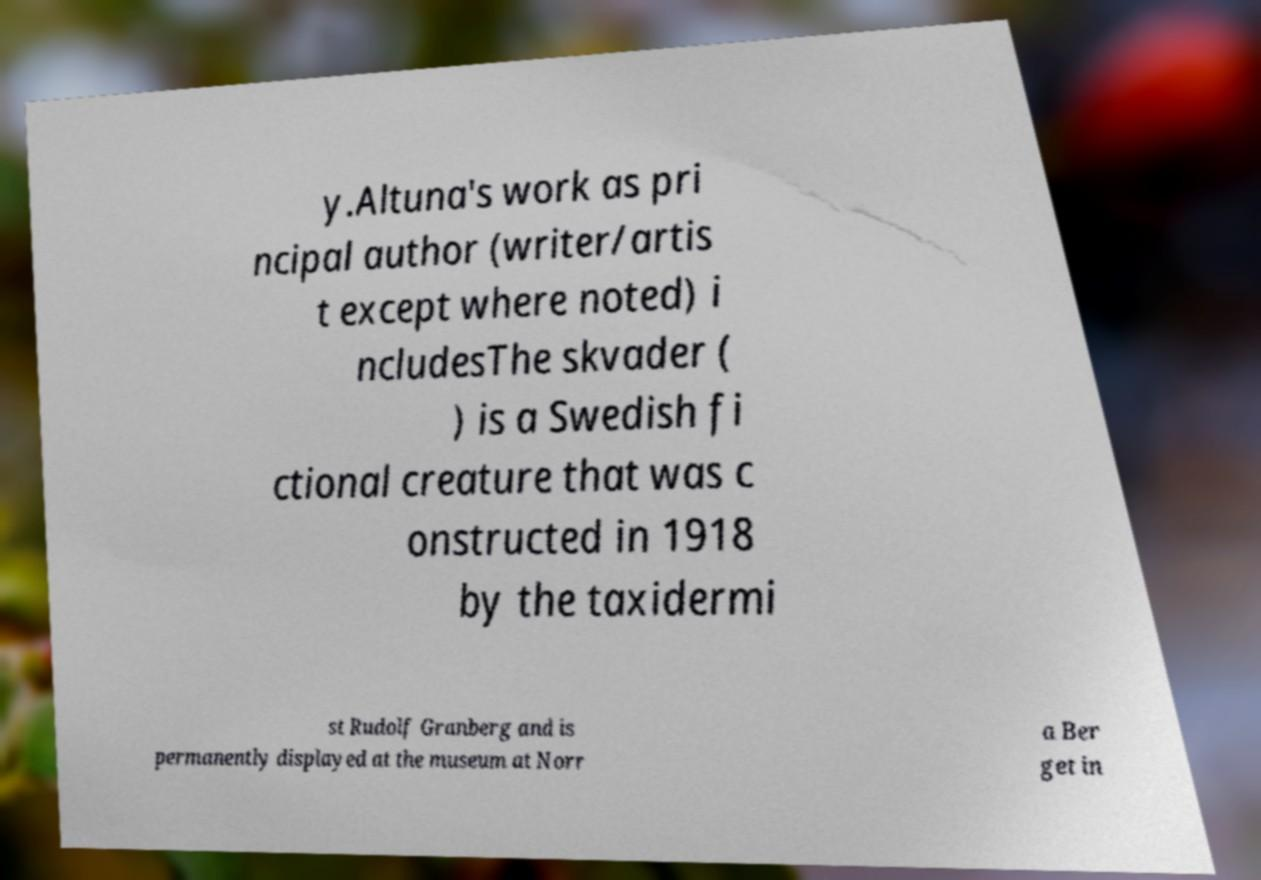Could you assist in decoding the text presented in this image and type it out clearly? y.Altuna's work as pri ncipal author (writer/artis t except where noted) i ncludesThe skvader ( ) is a Swedish fi ctional creature that was c onstructed in 1918 by the taxidermi st Rudolf Granberg and is permanently displayed at the museum at Norr a Ber get in 